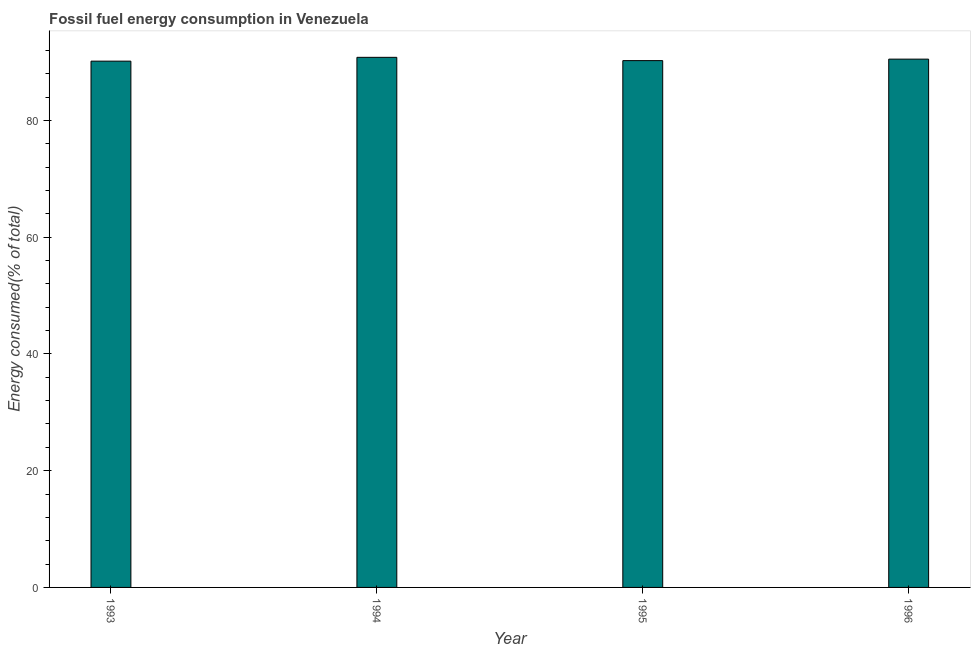What is the title of the graph?
Your answer should be compact. Fossil fuel energy consumption in Venezuela. What is the label or title of the Y-axis?
Your answer should be very brief. Energy consumed(% of total). What is the fossil fuel energy consumption in 1996?
Your response must be concise. 90.49. Across all years, what is the maximum fossil fuel energy consumption?
Provide a short and direct response. 90.8. Across all years, what is the minimum fossil fuel energy consumption?
Provide a short and direct response. 90.14. In which year was the fossil fuel energy consumption maximum?
Your answer should be compact. 1994. In which year was the fossil fuel energy consumption minimum?
Provide a succinct answer. 1993. What is the sum of the fossil fuel energy consumption?
Provide a short and direct response. 361.66. What is the difference between the fossil fuel energy consumption in 1994 and 1995?
Give a very brief answer. 0.56. What is the average fossil fuel energy consumption per year?
Provide a succinct answer. 90.42. What is the median fossil fuel energy consumption?
Your answer should be compact. 90.36. In how many years, is the fossil fuel energy consumption greater than 12 %?
Ensure brevity in your answer.  4. Is the difference between the fossil fuel energy consumption in 1993 and 1995 greater than the difference between any two years?
Your response must be concise. No. What is the difference between the highest and the second highest fossil fuel energy consumption?
Your response must be concise. 0.31. What is the difference between the highest and the lowest fossil fuel energy consumption?
Ensure brevity in your answer.  0.65. In how many years, is the fossil fuel energy consumption greater than the average fossil fuel energy consumption taken over all years?
Offer a very short reply. 2. Are all the bars in the graph horizontal?
Your response must be concise. No. How many years are there in the graph?
Ensure brevity in your answer.  4. Are the values on the major ticks of Y-axis written in scientific E-notation?
Your response must be concise. No. What is the Energy consumed(% of total) in 1993?
Make the answer very short. 90.14. What is the Energy consumed(% of total) in 1994?
Make the answer very short. 90.8. What is the Energy consumed(% of total) in 1995?
Keep it short and to the point. 90.23. What is the Energy consumed(% of total) in 1996?
Ensure brevity in your answer.  90.49. What is the difference between the Energy consumed(% of total) in 1993 and 1994?
Your answer should be very brief. -0.65. What is the difference between the Energy consumed(% of total) in 1993 and 1995?
Your answer should be compact. -0.09. What is the difference between the Energy consumed(% of total) in 1993 and 1996?
Your answer should be compact. -0.35. What is the difference between the Energy consumed(% of total) in 1994 and 1995?
Keep it short and to the point. 0.56. What is the difference between the Energy consumed(% of total) in 1994 and 1996?
Offer a very short reply. 0.31. What is the difference between the Energy consumed(% of total) in 1995 and 1996?
Keep it short and to the point. -0.26. What is the ratio of the Energy consumed(% of total) in 1993 to that in 1995?
Keep it short and to the point. 1. What is the ratio of the Energy consumed(% of total) in 1993 to that in 1996?
Your response must be concise. 1. What is the ratio of the Energy consumed(% of total) in 1994 to that in 1996?
Your answer should be very brief. 1. What is the ratio of the Energy consumed(% of total) in 1995 to that in 1996?
Provide a short and direct response. 1. 